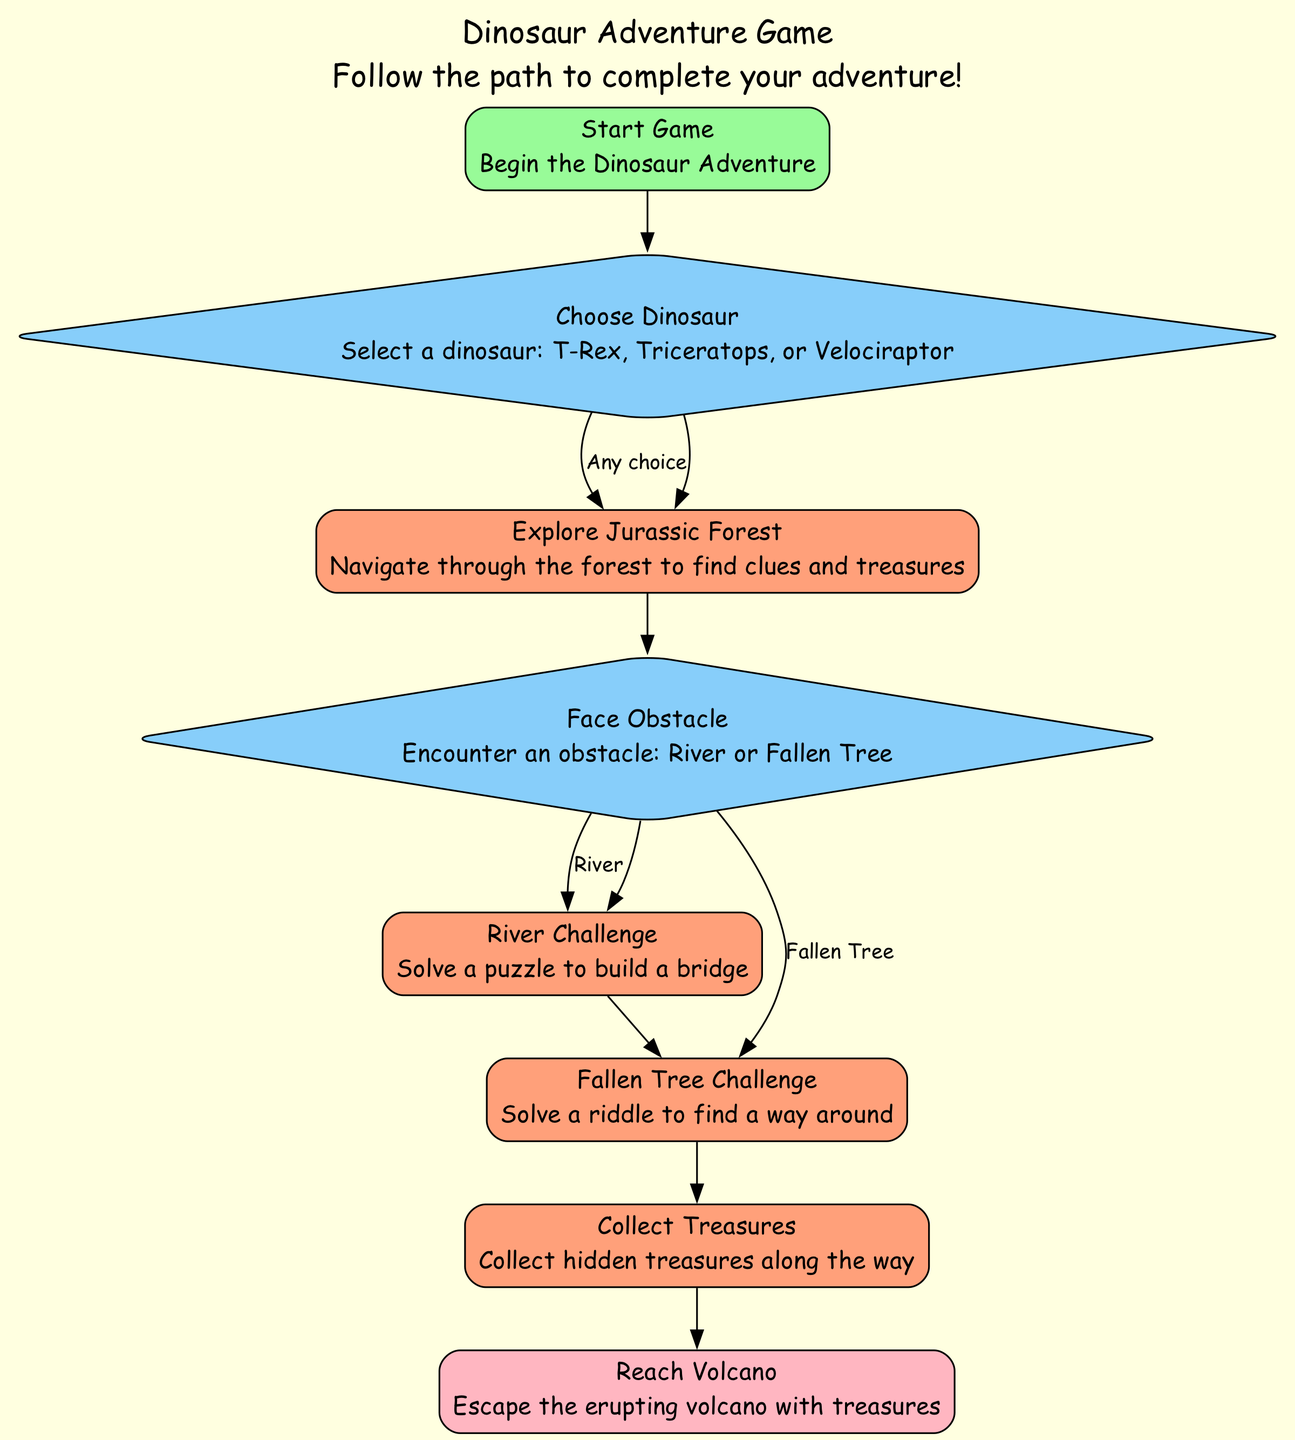What is the starting point of the game? The starting point of the game is indicated as "Start Game," which begins the adventure in the Dinosaur Adventure Game.
Answer: Start Game How many decisions are there in the flow chart? The flow chart contains two decision points: "Choose Dinosaur" and "Face Obstacle." Therefore, by counting each decision element, we find a total of two.
Answer: 2 What happens after you explore the Jurassic Forest? After exploring the Jurassic Forest, the next step is to "Face Obstacle." This indicates you will encounter an obstacle that you need to deal with.
Answer: Face Obstacle If you pick the T-Rex, what will you do next? If you choose the T-Rex, you will go to "Explore Jurassic Forest" next, as all dinosaur choices lead to the same exploration step regardless of which dinosaur is selected.
Answer: Explore Jurassic Forest What challenges can you face after the "Face Obstacle" decision? After making the decision to face an obstacle, you can either encounter the "River Challenge" or the "Fallen Tree Challenge," depending on what the obstacle is.
Answer: River Challenge or Fallen Tree Challenge Which node leads to reaching the volcano? The process "Collect Treasures" directly leads to the final node "Reach Volcano," indicating that after collecting treasures, you will proceed to escape the volcano.
Answer: Reach Volcano What color represents decision nodes in the diagram? Decision nodes are represented in light sky blue color, which is visually distinct in the flow chart.
Answer: Light sky blue How many process steps are there in total? There are three process steps in the diagram: "Explore Jurassic Forest," "River Challenge," and "Fallen Tree Challenge," in addition to "Collect Treasures." Therefore, we need to count all the process elements to get the total.
Answer: 4 